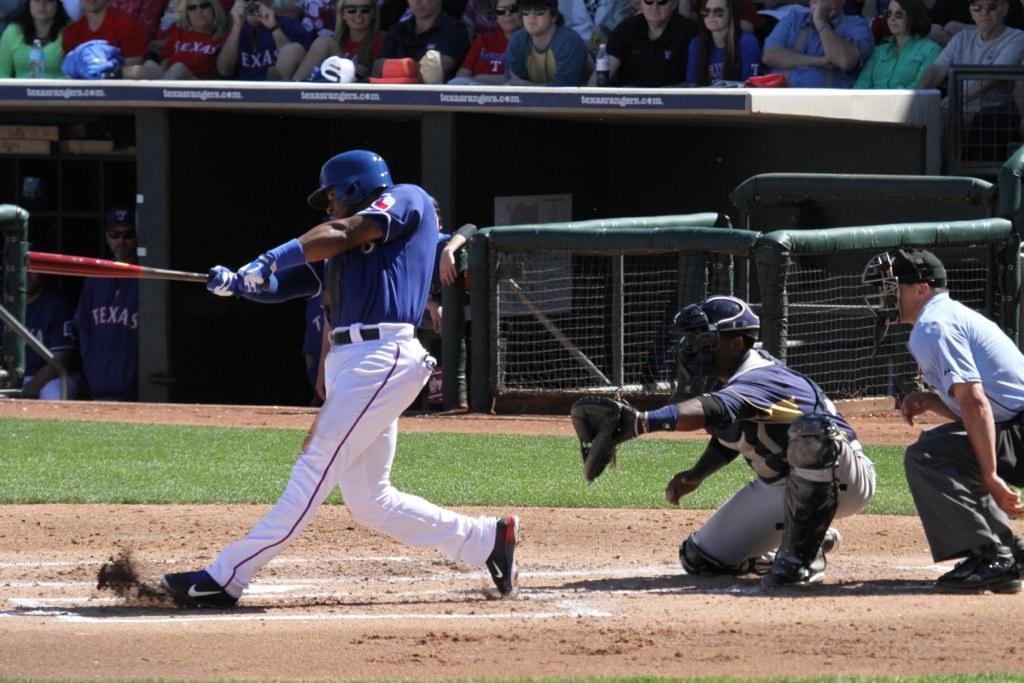<image>
Write a terse but informative summary of the picture. A baseball player batting at home plate from the Texas Rangers. 